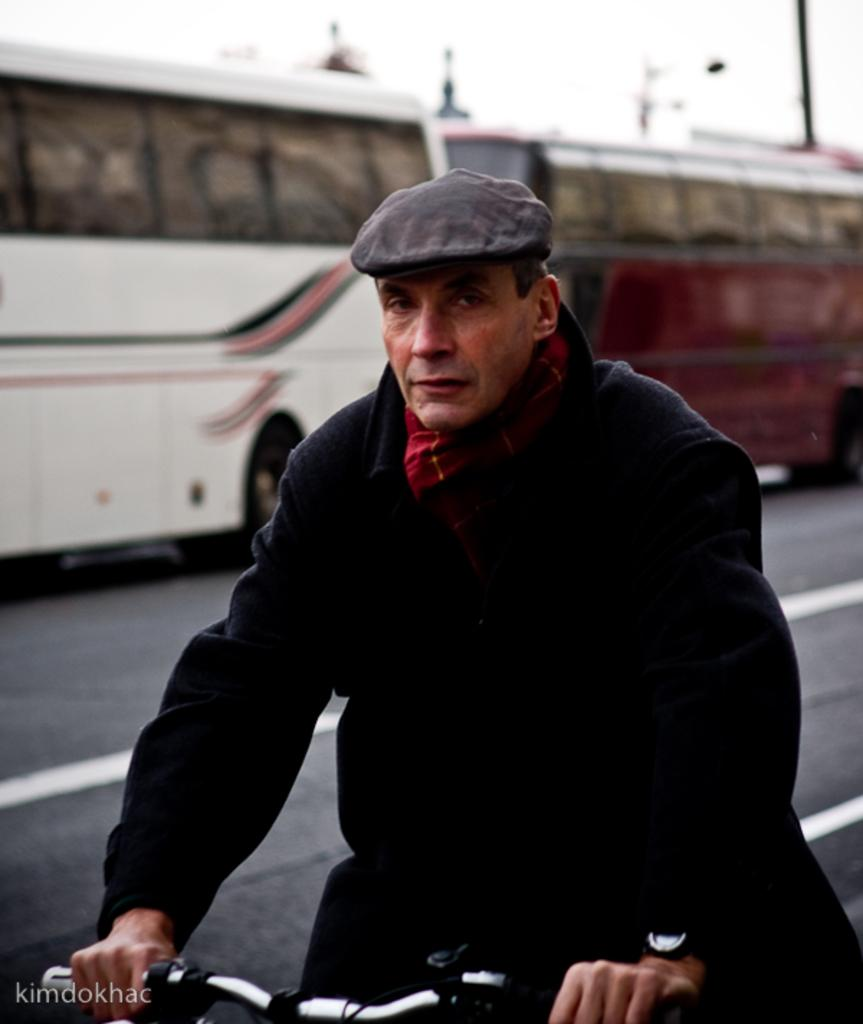What is the person in the image wearing? The person in the image is wearing a black jacket. What mode of transportation is the person using? The person is on a cycle. What can be seen in the background of the image? There are buses in the background of the image. Where are the buses located in the image? The buses are on the road. What type of books is the person reading while riding the cycle in the image? There are no books present in the image; the person is riding a cycle and wearing a black jacket. 